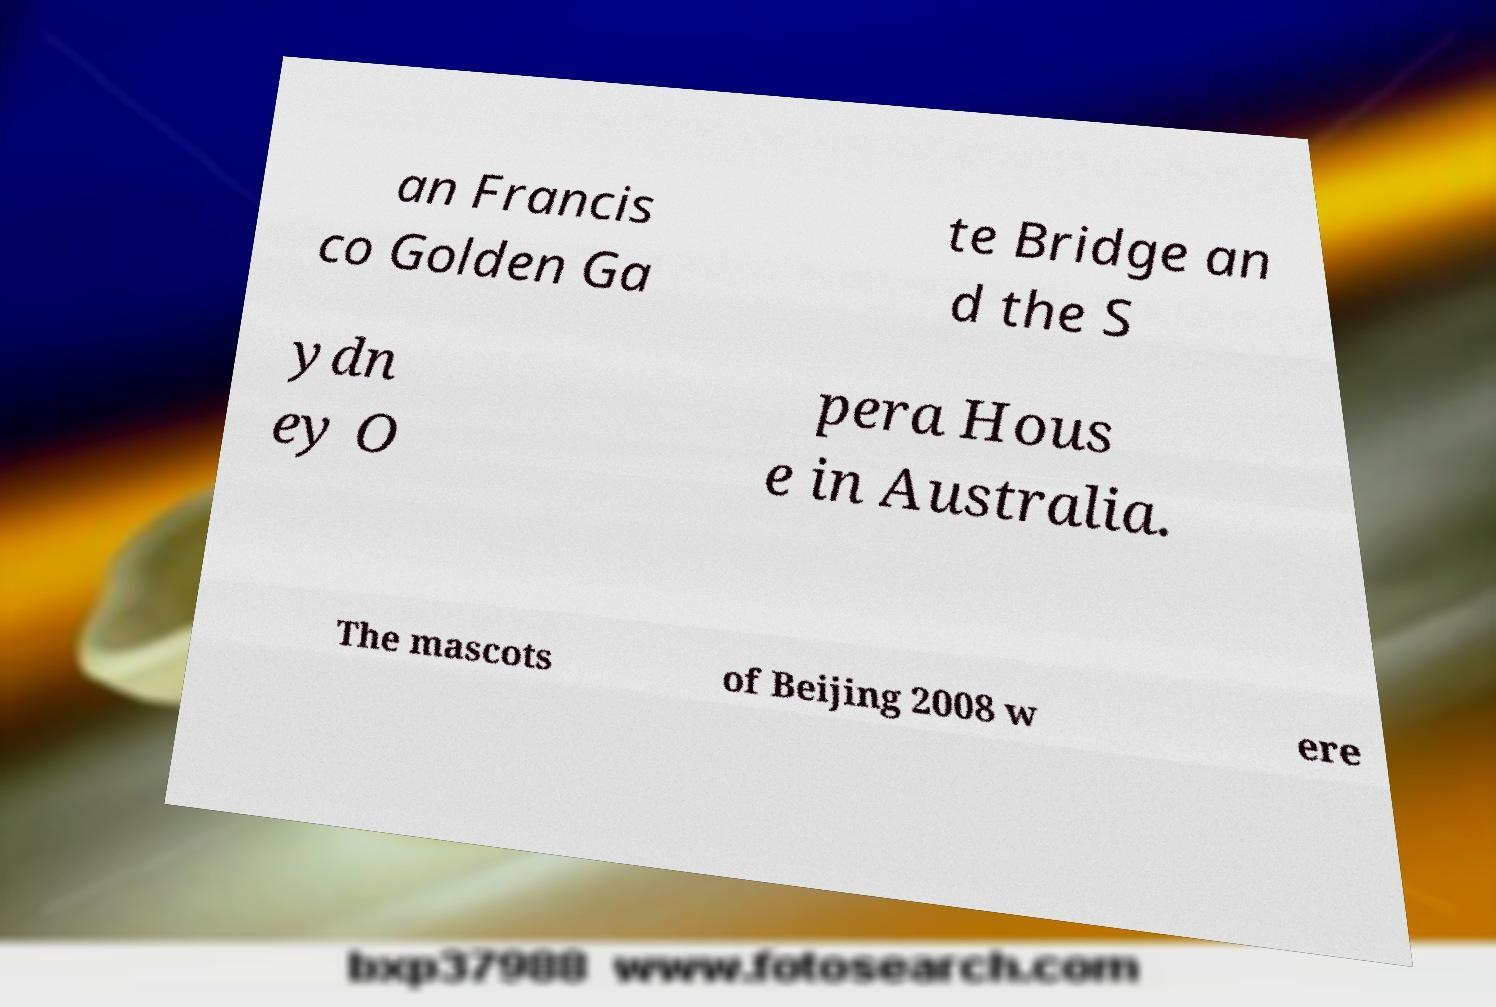I need the written content from this picture converted into text. Can you do that? an Francis co Golden Ga te Bridge an d the S ydn ey O pera Hous e in Australia. The mascots of Beijing 2008 w ere 